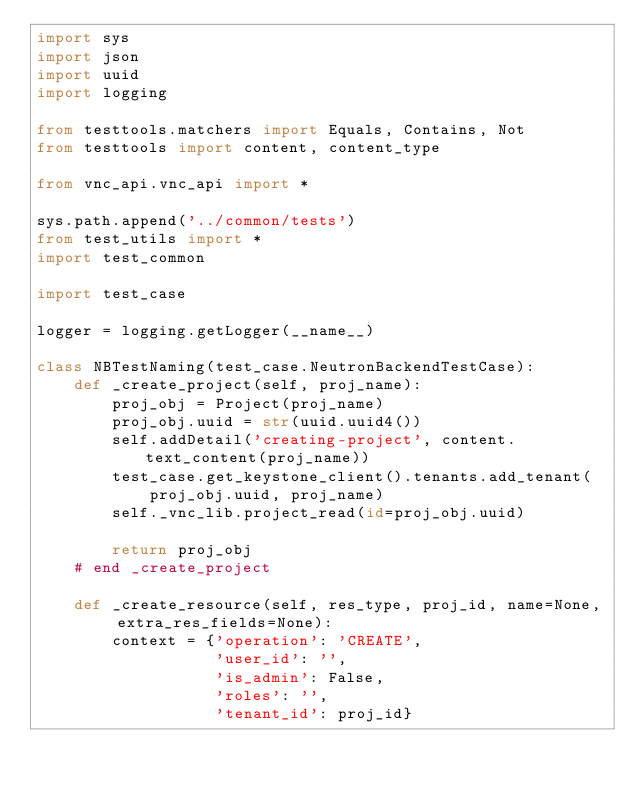Convert code to text. <code><loc_0><loc_0><loc_500><loc_500><_Python_>import sys
import json
import uuid
import logging

from testtools.matchers import Equals, Contains, Not
from testtools import content, content_type

from vnc_api.vnc_api import *

sys.path.append('../common/tests')
from test_utils import *
import test_common

import test_case

logger = logging.getLogger(__name__)

class NBTestNaming(test_case.NeutronBackendTestCase):
    def _create_project(self, proj_name):
        proj_obj = Project(proj_name)
        proj_obj.uuid = str(uuid.uuid4())
        self.addDetail('creating-project', content.text_content(proj_name))
        test_case.get_keystone_client().tenants.add_tenant(
            proj_obj.uuid, proj_name)
        self._vnc_lib.project_read(id=proj_obj.uuid)

        return proj_obj
    # end _create_project
        
    def _create_resource(self, res_type, proj_id, name=None, extra_res_fields=None):
        context = {'operation': 'CREATE',
                   'user_id': '',
                   'is_admin': False,
                   'roles': '',
                   'tenant_id': proj_id}</code> 